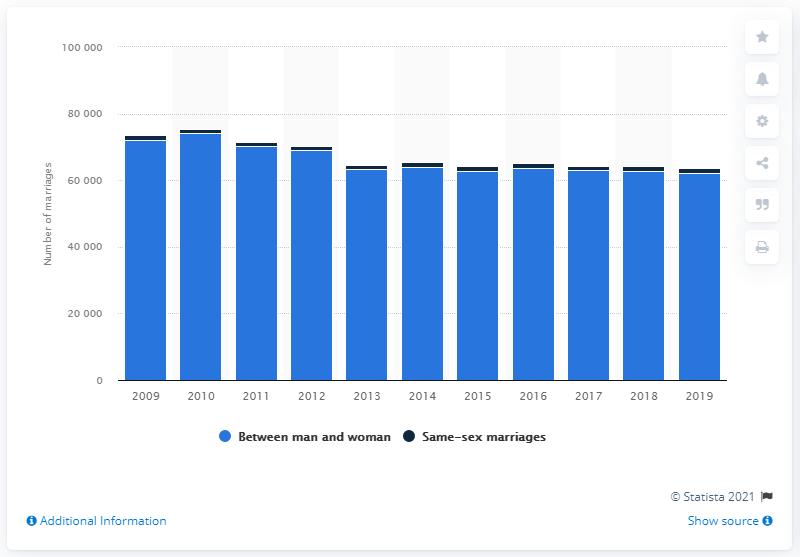Give some essential details in this illustration. By the year 2019, both straight and homosexual marriages had seen a decrease in the number of marriages. In 2016, the number of heterosexual marriages increased once again. 